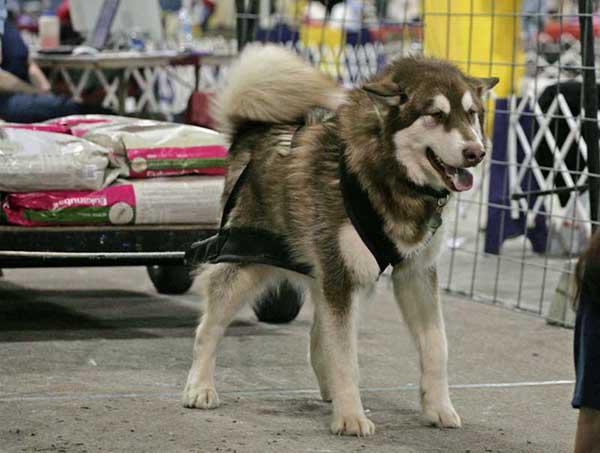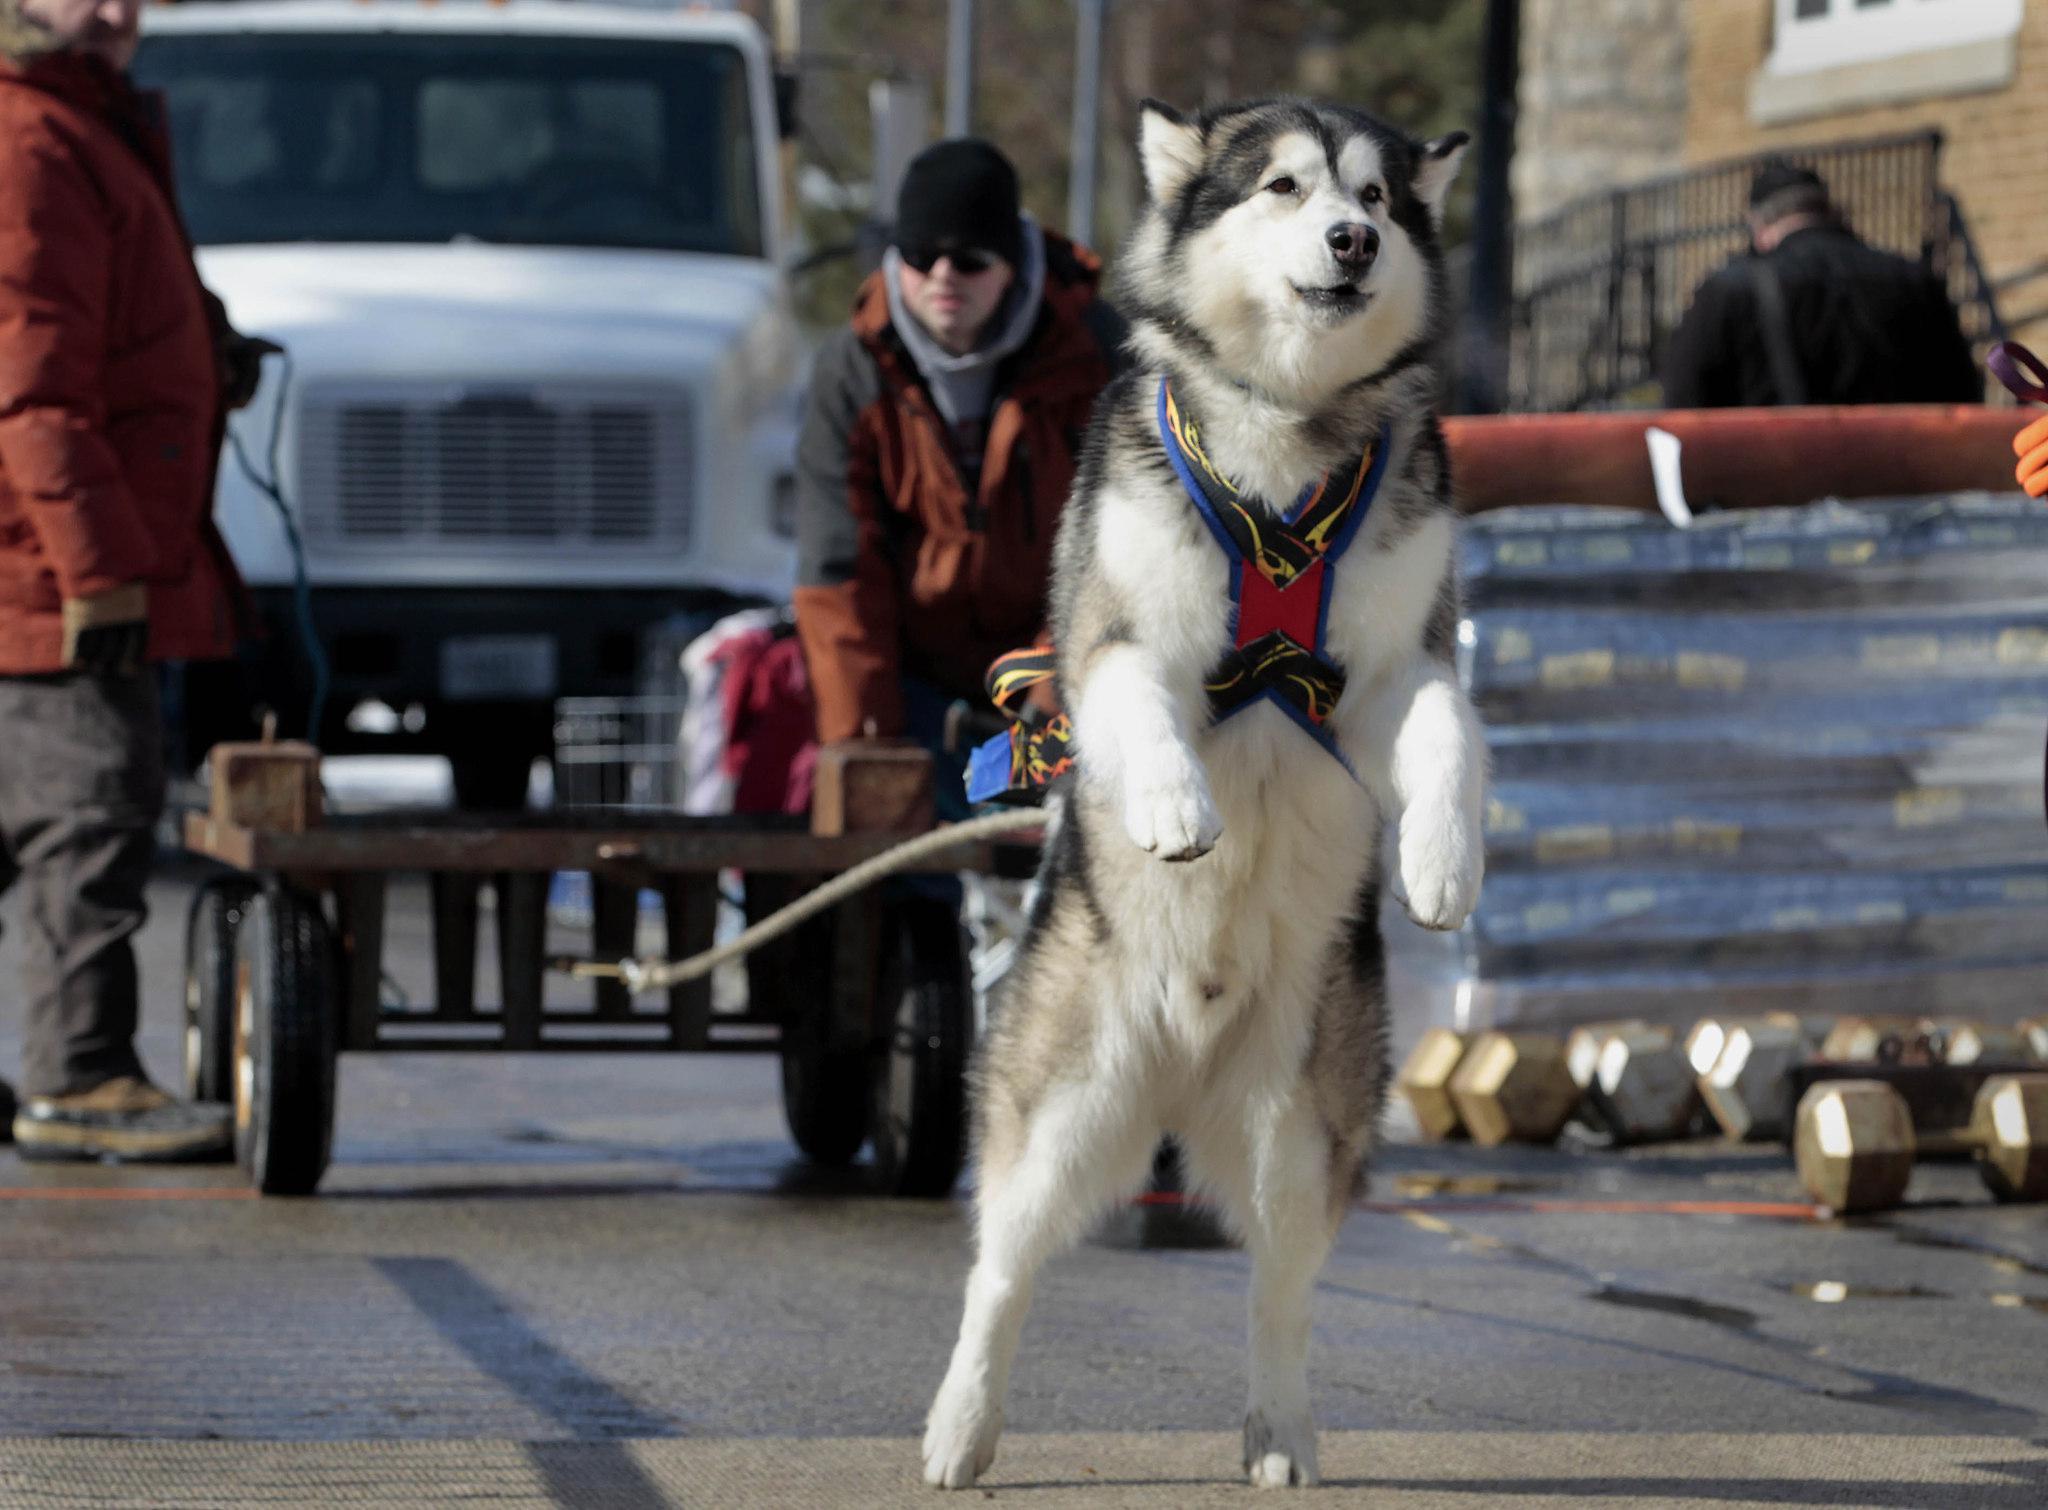The first image is the image on the left, the second image is the image on the right. Assess this claim about the two images: "One image shows a leftward-turned dog in a harness leaning forward in profile as it strains to pull something that is out of sight, and the other image shows a dog standing on all fours with its head raised and mouth open.". Correct or not? Answer yes or no. No. The first image is the image on the left, the second image is the image on the right. For the images displayed, is the sentence "A dog is pulling a cart using only its hind legs in one of the pictures." factually correct? Answer yes or no. Yes. 